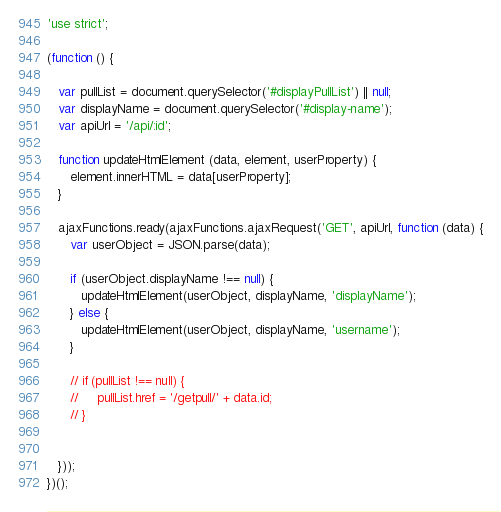Convert code to text. <code><loc_0><loc_0><loc_500><loc_500><_JavaScript_>'use strict';

(function () {

   var pullList = document.querySelector('#displayPullList') || null;
   var displayName = document.querySelector('#display-name');
   var apiUrl = '/api/:id';

   function updateHtmlElement (data, element, userProperty) {
      element.innerHTML = data[userProperty];
   }

   ajaxFunctions.ready(ajaxFunctions.ajaxRequest('GET', apiUrl, function (data) {
      var userObject = JSON.parse(data);

      if (userObject.displayName !== null) {
         updateHtmlElement(userObject, displayName, 'displayName');
      } else {
         updateHtmlElement(userObject, displayName, 'username');
      }

      // if (pullList !== null) {
      //     pullList.href = '/getpull/' + data.id;
      // }


   }));
})();</code> 